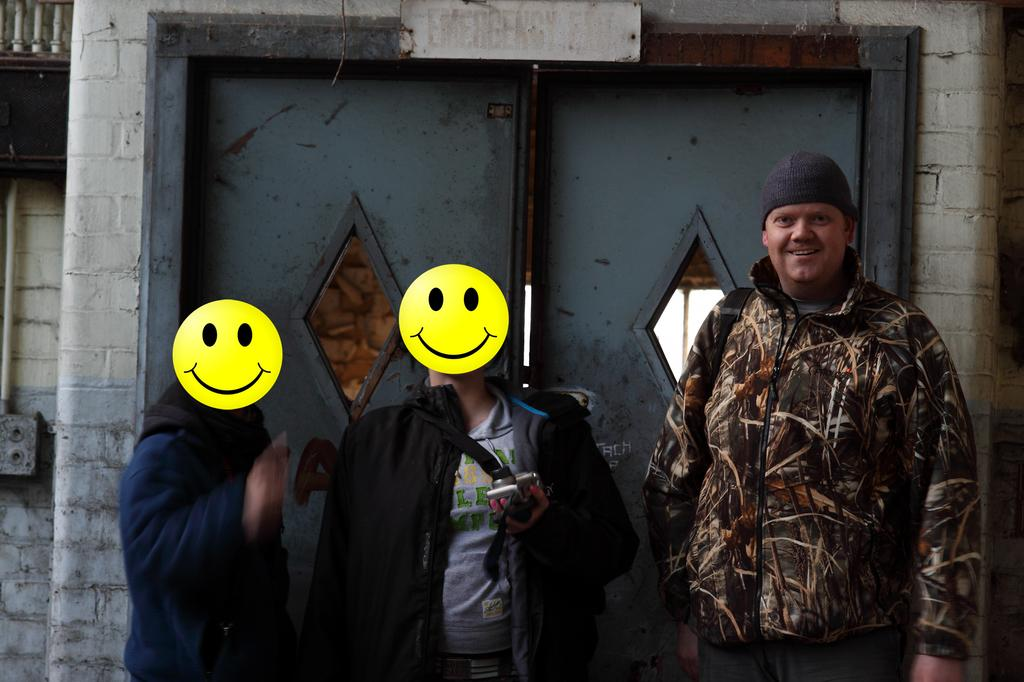How many people are present in the image? There are three persons standing in the image. What is one of the persons holding? There is a person holding a camera in the image. What can be seen in the background of the image? There is a door and a board in the background of the image. We start by identifying the number of people in the image and then describe what one of them is holding. Finally, we mention the objects that can be seen in the background. Can you see a sock stuck in the quicksand in the image? There is no quicksand or sock present in the image. What type of plate is being used by the person holding the camera? There is no plate visible in the image; the person is holding a camera. 